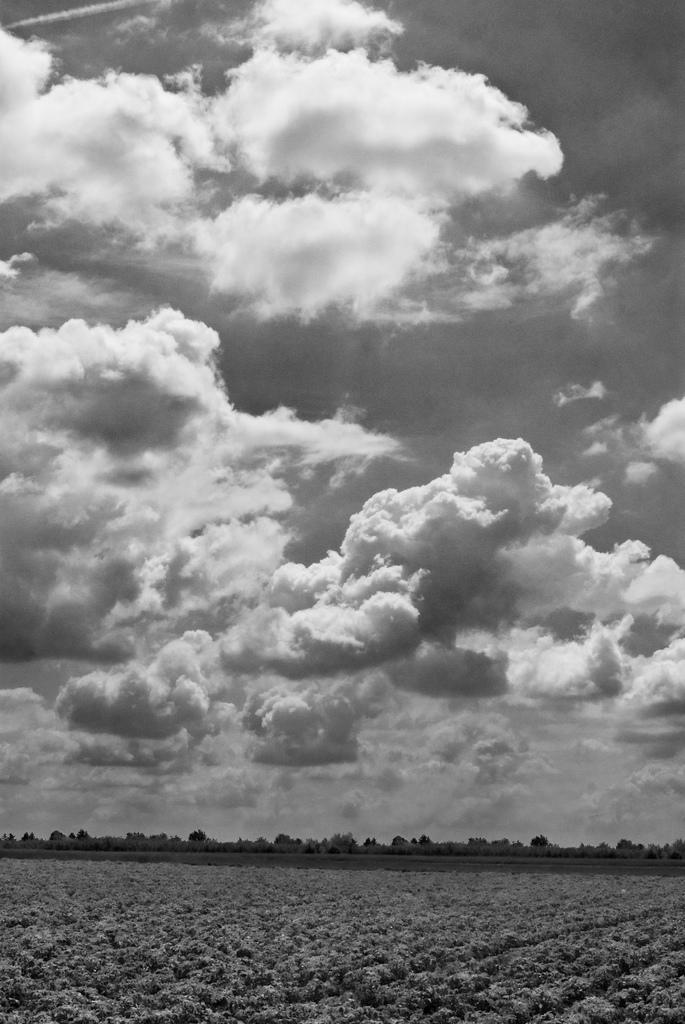How would you summarize this image in a sentence or two? In this picture there are few plants and there are trees in the background and the sky is cloudy. 